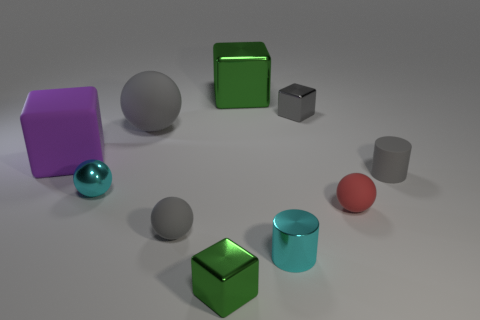What size is the purple object that is the same material as the large ball?
Provide a short and direct response. Large. Does the tiny red object have the same shape as the tiny gray rubber object that is on the left side of the gray metal block?
Keep it short and to the point. Yes. What number of cyan spheres have the same size as the red matte ball?
Provide a short and direct response. 1. There is a cyan object left of the large metal thing; does it have the same shape as the small rubber thing in front of the tiny red ball?
Your answer should be very brief. Yes. There is a small matte thing that is the same color as the rubber cylinder; what shape is it?
Offer a terse response. Sphere. The small metal cube that is in front of the cyan shiny cylinder on the left side of the small red object is what color?
Offer a very short reply. Green. What color is the large shiny object that is the same shape as the purple matte thing?
Your response must be concise. Green. What is the size of the purple object that is the same shape as the big green metallic thing?
Offer a very short reply. Large. There is a tiny cylinder that is in front of the tiny matte cylinder; what is its material?
Provide a succinct answer. Metal. Are there fewer gray blocks left of the gray metal object than objects?
Keep it short and to the point. Yes. 